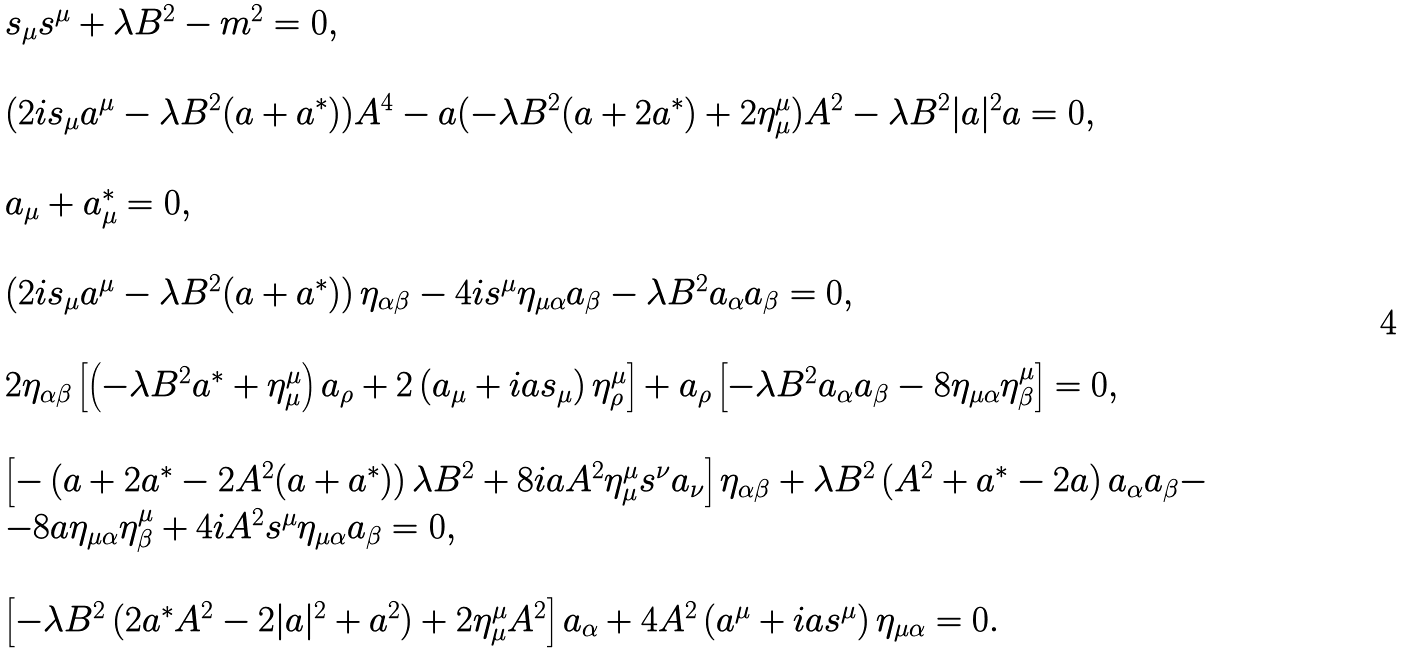<formula> <loc_0><loc_0><loc_500><loc_500>\begin{array} { l } s _ { \mu } s ^ { \mu } + \lambda B ^ { 2 } - m ^ { 2 } = 0 , \\ \\ ( 2 i s _ { \mu } a ^ { \mu } - \lambda B ^ { 2 } ( a + a ^ { * } ) ) A ^ { 4 } - a ( - \lambda B ^ { 2 } ( a + 2 a ^ { * } ) + 2 \eta ^ { \mu } _ { \mu } ) A ^ { 2 } - \lambda B ^ { 2 } | a | ^ { 2 } a = 0 , \\ \\ a _ { \mu } + a ^ { * } _ { \mu } = 0 , \\ \\ \left ( 2 i s _ { \mu } a ^ { \mu } - \lambda B ^ { 2 } ( a + a ^ { * } ) \right ) \eta _ { \alpha \beta } - 4 i s ^ { \mu } \eta _ { \mu \alpha } a _ { \beta } - \lambda B ^ { 2 } a _ { \alpha } a _ { \beta } = 0 , \\ \\ 2 \eta _ { \alpha \beta } \left [ \left ( - \lambda B ^ { 2 } a ^ { * } + \eta ^ { \mu } _ { \mu } \right ) a _ { \rho } + 2 \left ( a _ { \mu } + i a s _ { \mu } \right ) \eta ^ { \mu } _ { \rho } \right ] + a _ { \rho } \left [ - \lambda B ^ { 2 } a _ { \alpha } a _ { \beta } - 8 \eta _ { \mu \alpha } \eta ^ { \mu } _ { \beta } \right ] = 0 , \\ \\ \left [ - \left ( a + 2 a ^ { * } - 2 A ^ { 2 } ( a + a ^ { * } ) \right ) \lambda B ^ { 2 } + 8 i a A ^ { 2 } \eta ^ { \mu } _ { \mu } s ^ { \nu } a _ { \nu } \right ] \eta _ { \alpha \beta } + \lambda B ^ { 2 } \left ( A ^ { 2 } + a ^ { * } - 2 a \right ) a _ { \alpha } a _ { \beta } - \\ - 8 a \eta _ { \mu \alpha } \eta ^ { \mu } _ { \beta } + 4 i A ^ { 2 } s ^ { \mu } \eta _ { \mu \alpha } a _ { \beta } = 0 , \\ \\ \left [ - \lambda B ^ { 2 } \left ( 2 a ^ { * } A ^ { 2 } - 2 | a | ^ { 2 } + a ^ { 2 } \right ) + 2 \eta ^ { \mu } _ { \mu } A ^ { 2 } \right ] a _ { \alpha } + 4 A ^ { 2 } \left ( a ^ { \mu } + i a s ^ { \mu } \right ) \eta _ { \mu \alpha } = 0 . \end{array}</formula> 